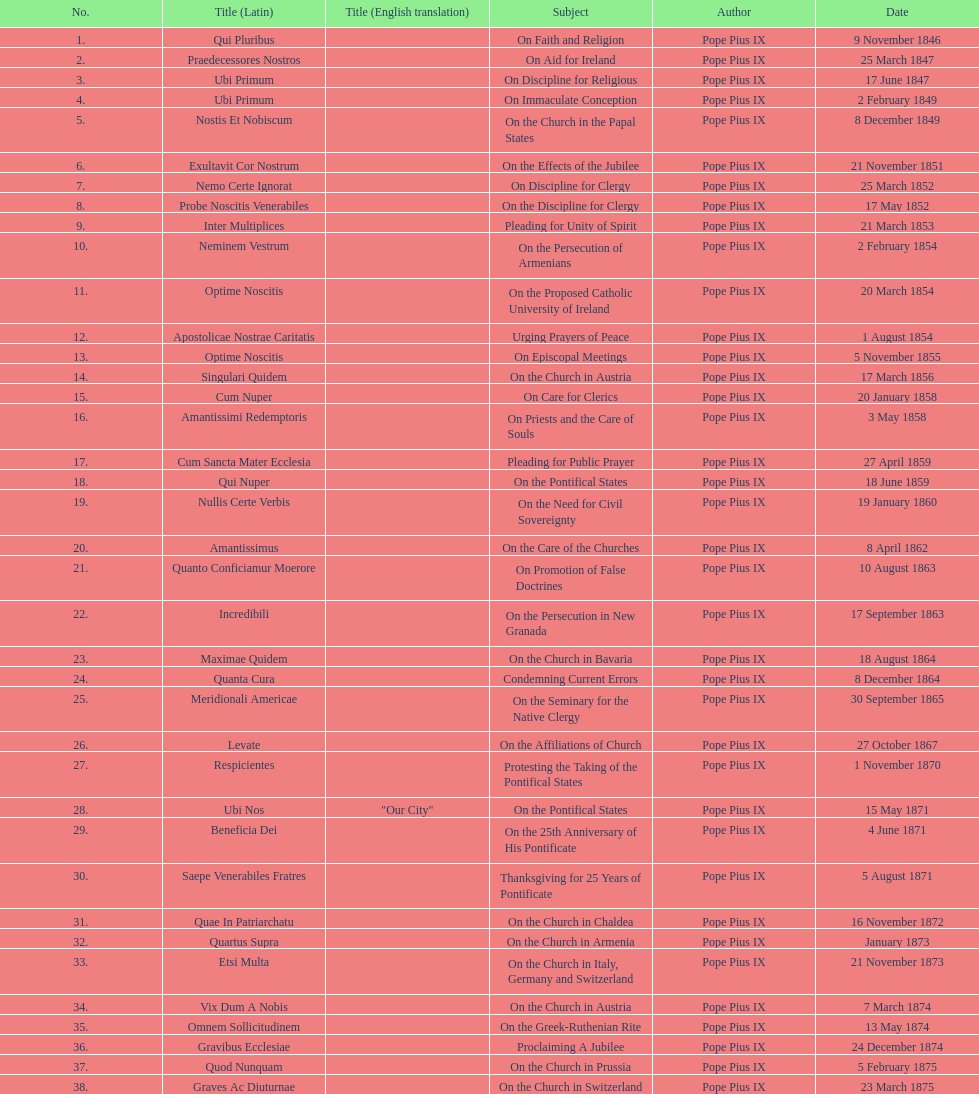In the first 10 years of his reign, how many encyclicals did pope pius ix issue? 14. 